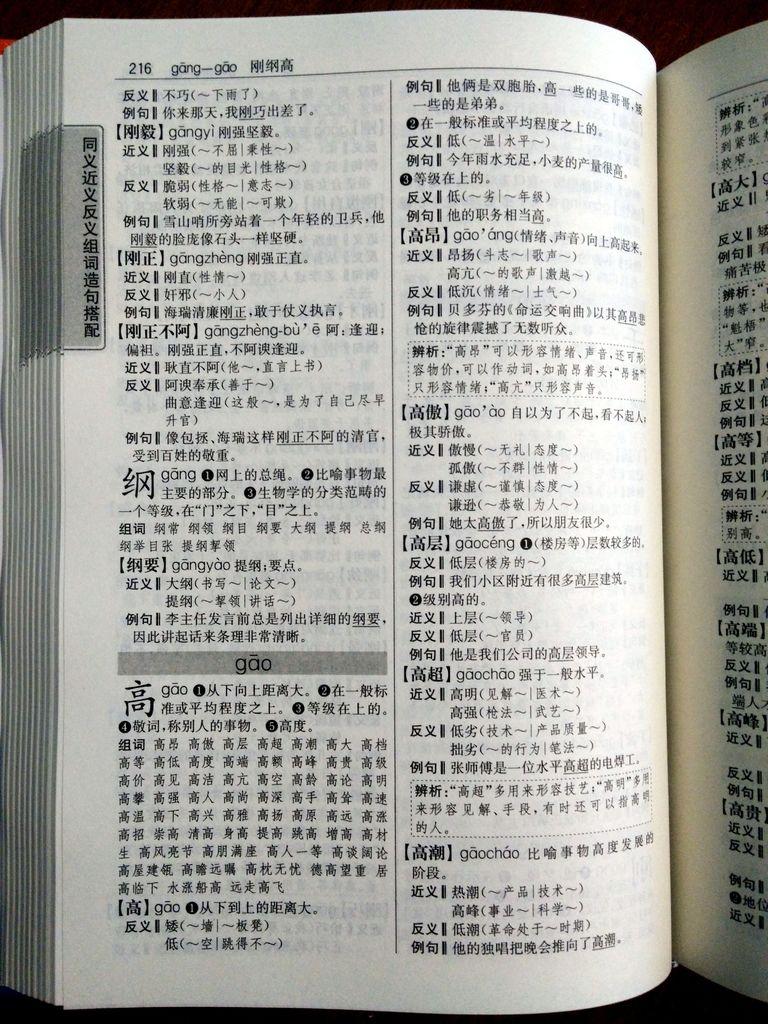What page number is this?
Keep it short and to the point. 216. 